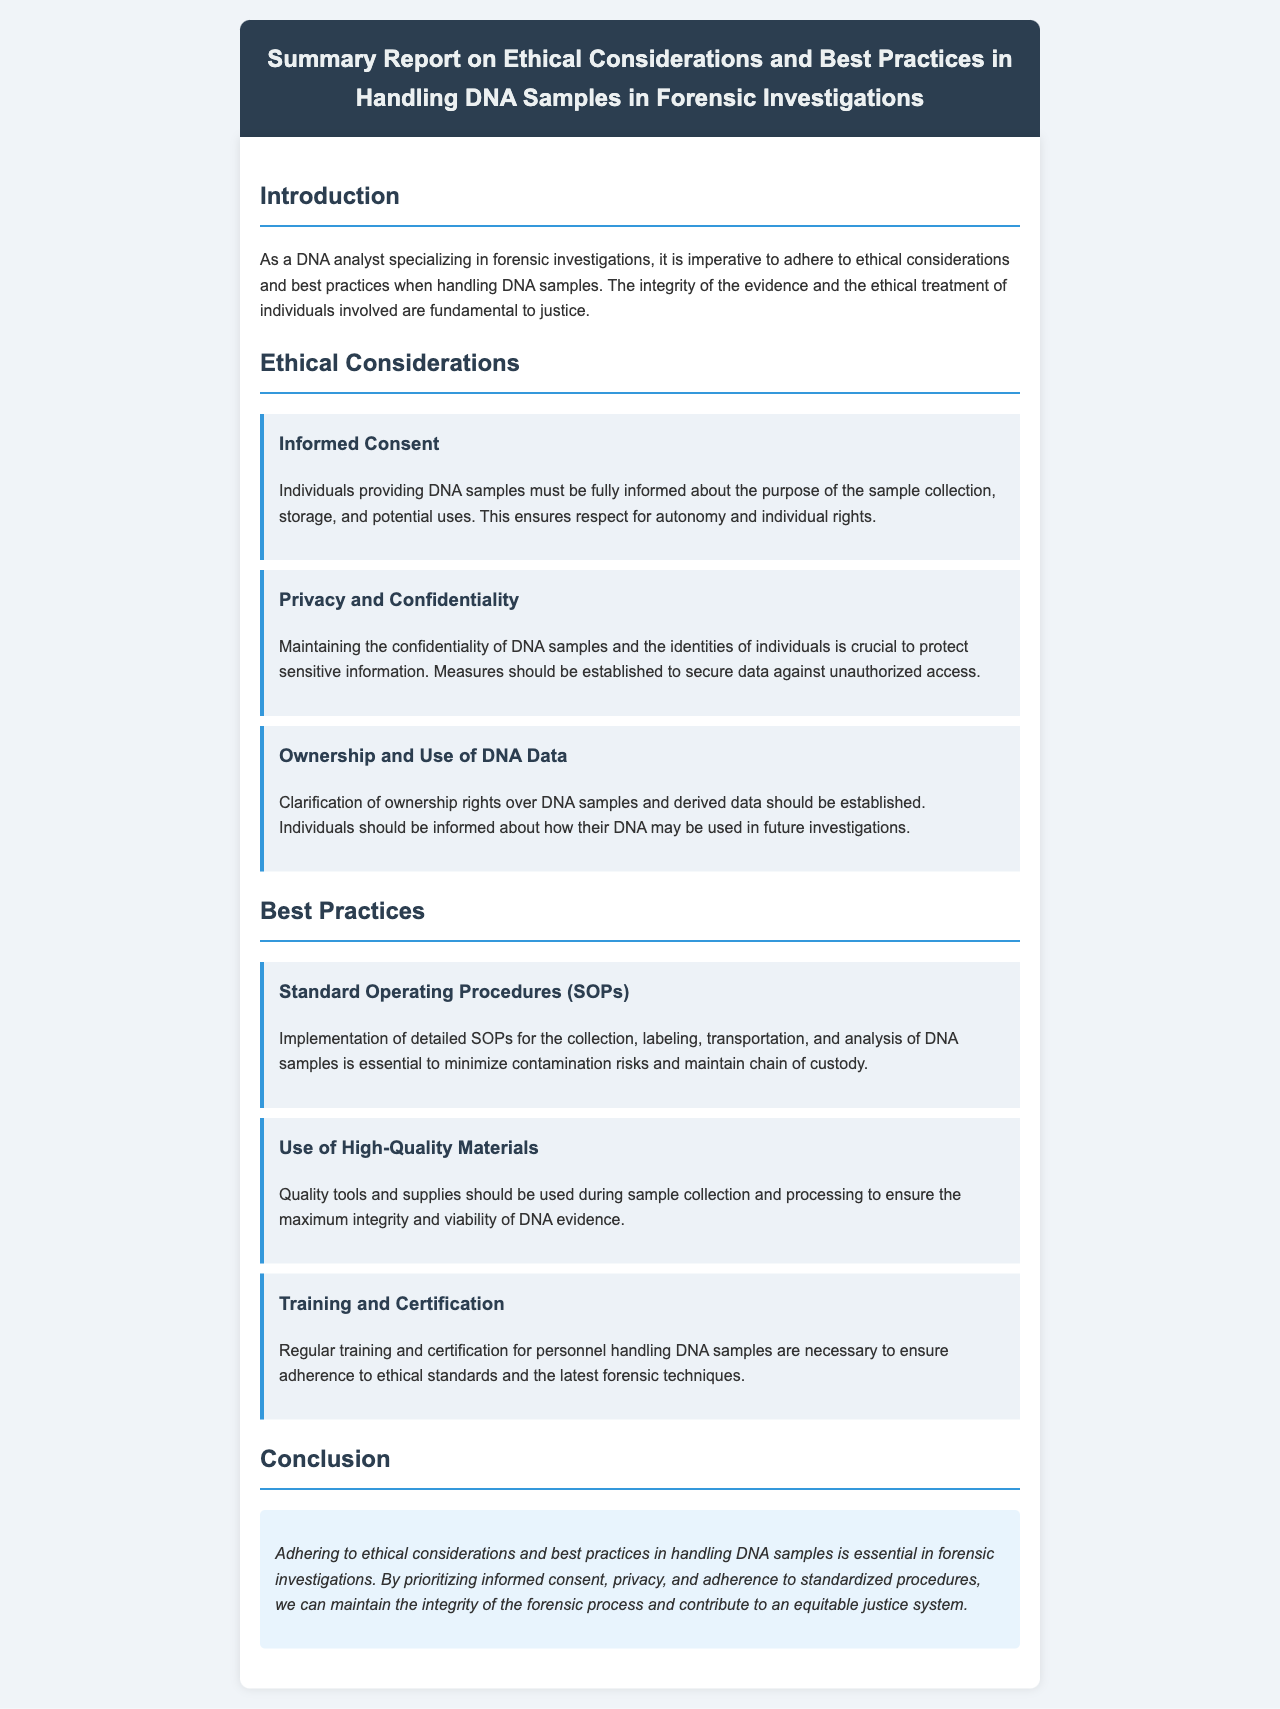What is the title of the report? The title is clearly stated at the top of the document, summarizing the main focus areas.
Answer: Summary Report on Ethical Considerations and Best Practices in Handling DNA Samples in Forensic Investigations What section discusses Informed Consent? The document is structured into sections; Informed Consent is highlighted under Ethical Considerations.
Answer: Ethical Considerations What is one key aspect of Privacy and Confidentiality? The document specifies that maintaining confidentiality is crucial to protect sensitive information, which is a primary concern in handling DNA samples.
Answer: Protect sensitive information What are SOPs? SOPs are mentioned in the Best Practices section, and their importance in forensic investigations is emphasized.
Answer: Standard Operating Procedures What is necessary for personnel handling DNA samples? The document outlines a specific requirement for personnel involved in DNA analysis to maintain high standards and skills.
Answer: Regular training and certification What does the conclusion emphasize? The conclusion summarizes the importance of the discussed ethical considerations and best practices in maintaining integrity in forensic investigations.
Answer: Maintain the integrity of the forensic process How many points are listed under Ethical Considerations? There are multiple key points under this section, indicating the various ethical issues that need consideration.
Answer: Three points What is the implication of ownership rights as discussed in the report? The document highlights the need for clarity regarding who holds the rights over DNA samples and usage, which is crucial for ethical practices.
Answer: Clarification of ownership rights Which section includes the point about using high-quality materials? The sourcing and handling of materials for DNA sample processing is discussed in connection with recommended best practices.
Answer: Best Practices 